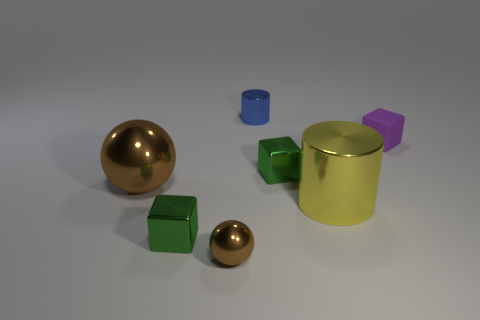How many brown things are in front of the yellow cylinder that is right of the small block in front of the big shiny ball? In the image, when looking for the brown items positioned in front of the yellow cylinder, which itself is to the right of the small block positioned in front of the big shiny ball, there appears to be one brown item meeting these criteria. 